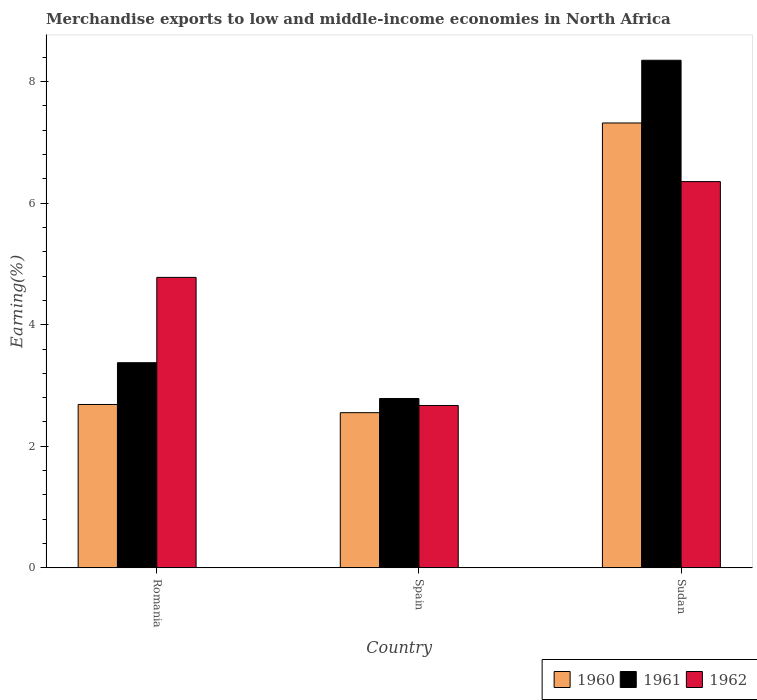How many groups of bars are there?
Keep it short and to the point. 3. Are the number of bars per tick equal to the number of legend labels?
Provide a short and direct response. Yes. How many bars are there on the 3rd tick from the left?
Your response must be concise. 3. How many bars are there on the 3rd tick from the right?
Offer a very short reply. 3. What is the label of the 3rd group of bars from the left?
Make the answer very short. Sudan. In how many cases, is the number of bars for a given country not equal to the number of legend labels?
Offer a very short reply. 0. What is the percentage of amount earned from merchandise exports in 1962 in Sudan?
Your response must be concise. 6.35. Across all countries, what is the maximum percentage of amount earned from merchandise exports in 1962?
Ensure brevity in your answer.  6.35. Across all countries, what is the minimum percentage of amount earned from merchandise exports in 1962?
Keep it short and to the point. 2.67. In which country was the percentage of amount earned from merchandise exports in 1962 maximum?
Ensure brevity in your answer.  Sudan. What is the total percentage of amount earned from merchandise exports in 1960 in the graph?
Your answer should be very brief. 12.56. What is the difference between the percentage of amount earned from merchandise exports in 1961 in Romania and that in Sudan?
Make the answer very short. -4.98. What is the difference between the percentage of amount earned from merchandise exports in 1962 in Romania and the percentage of amount earned from merchandise exports in 1960 in Sudan?
Your answer should be compact. -2.54. What is the average percentage of amount earned from merchandise exports in 1962 per country?
Your response must be concise. 4.6. What is the difference between the percentage of amount earned from merchandise exports of/in 1962 and percentage of amount earned from merchandise exports of/in 1960 in Spain?
Ensure brevity in your answer.  0.12. In how many countries, is the percentage of amount earned from merchandise exports in 1961 greater than 6.8 %?
Provide a succinct answer. 1. What is the ratio of the percentage of amount earned from merchandise exports in 1961 in Romania to that in Spain?
Your answer should be compact. 1.21. Is the difference between the percentage of amount earned from merchandise exports in 1962 in Romania and Sudan greater than the difference between the percentage of amount earned from merchandise exports in 1960 in Romania and Sudan?
Keep it short and to the point. Yes. What is the difference between the highest and the second highest percentage of amount earned from merchandise exports in 1961?
Your response must be concise. 5.57. What is the difference between the highest and the lowest percentage of amount earned from merchandise exports in 1962?
Your response must be concise. 3.68. In how many countries, is the percentage of amount earned from merchandise exports in 1961 greater than the average percentage of amount earned from merchandise exports in 1961 taken over all countries?
Keep it short and to the point. 1. Is it the case that in every country, the sum of the percentage of amount earned from merchandise exports in 1960 and percentage of amount earned from merchandise exports in 1962 is greater than the percentage of amount earned from merchandise exports in 1961?
Offer a terse response. Yes. What is the difference between two consecutive major ticks on the Y-axis?
Offer a very short reply. 2. Does the graph contain any zero values?
Provide a short and direct response. No. Does the graph contain grids?
Ensure brevity in your answer.  No. Where does the legend appear in the graph?
Ensure brevity in your answer.  Bottom right. How many legend labels are there?
Provide a short and direct response. 3. What is the title of the graph?
Make the answer very short. Merchandise exports to low and middle-income economies in North Africa. What is the label or title of the X-axis?
Ensure brevity in your answer.  Country. What is the label or title of the Y-axis?
Keep it short and to the point. Earning(%). What is the Earning(%) in 1960 in Romania?
Make the answer very short. 2.69. What is the Earning(%) in 1961 in Romania?
Provide a short and direct response. 3.37. What is the Earning(%) in 1962 in Romania?
Your answer should be compact. 4.78. What is the Earning(%) of 1960 in Spain?
Offer a terse response. 2.55. What is the Earning(%) of 1961 in Spain?
Make the answer very short. 2.79. What is the Earning(%) of 1962 in Spain?
Your answer should be compact. 2.67. What is the Earning(%) of 1960 in Sudan?
Provide a short and direct response. 7.32. What is the Earning(%) in 1961 in Sudan?
Offer a very short reply. 8.35. What is the Earning(%) of 1962 in Sudan?
Provide a succinct answer. 6.35. Across all countries, what is the maximum Earning(%) in 1960?
Offer a terse response. 7.32. Across all countries, what is the maximum Earning(%) of 1961?
Your answer should be compact. 8.35. Across all countries, what is the maximum Earning(%) in 1962?
Ensure brevity in your answer.  6.35. Across all countries, what is the minimum Earning(%) of 1960?
Your response must be concise. 2.55. Across all countries, what is the minimum Earning(%) in 1961?
Offer a very short reply. 2.79. Across all countries, what is the minimum Earning(%) in 1962?
Keep it short and to the point. 2.67. What is the total Earning(%) in 1960 in the graph?
Ensure brevity in your answer.  12.56. What is the total Earning(%) of 1961 in the graph?
Your answer should be very brief. 14.51. What is the total Earning(%) in 1962 in the graph?
Offer a very short reply. 13.8. What is the difference between the Earning(%) in 1960 in Romania and that in Spain?
Provide a short and direct response. 0.13. What is the difference between the Earning(%) in 1961 in Romania and that in Spain?
Your response must be concise. 0.59. What is the difference between the Earning(%) of 1962 in Romania and that in Spain?
Make the answer very short. 2.11. What is the difference between the Earning(%) of 1960 in Romania and that in Sudan?
Ensure brevity in your answer.  -4.63. What is the difference between the Earning(%) of 1961 in Romania and that in Sudan?
Provide a short and direct response. -4.98. What is the difference between the Earning(%) in 1962 in Romania and that in Sudan?
Provide a short and direct response. -1.58. What is the difference between the Earning(%) in 1960 in Spain and that in Sudan?
Provide a short and direct response. -4.77. What is the difference between the Earning(%) of 1961 in Spain and that in Sudan?
Offer a very short reply. -5.57. What is the difference between the Earning(%) in 1962 in Spain and that in Sudan?
Ensure brevity in your answer.  -3.68. What is the difference between the Earning(%) in 1960 in Romania and the Earning(%) in 1961 in Spain?
Offer a very short reply. -0.1. What is the difference between the Earning(%) of 1960 in Romania and the Earning(%) of 1962 in Spain?
Your answer should be compact. 0.02. What is the difference between the Earning(%) in 1961 in Romania and the Earning(%) in 1962 in Spain?
Give a very brief answer. 0.7. What is the difference between the Earning(%) of 1960 in Romania and the Earning(%) of 1961 in Sudan?
Provide a short and direct response. -5.67. What is the difference between the Earning(%) of 1960 in Romania and the Earning(%) of 1962 in Sudan?
Provide a short and direct response. -3.67. What is the difference between the Earning(%) of 1961 in Romania and the Earning(%) of 1962 in Sudan?
Keep it short and to the point. -2.98. What is the difference between the Earning(%) in 1960 in Spain and the Earning(%) in 1961 in Sudan?
Ensure brevity in your answer.  -5.8. What is the difference between the Earning(%) of 1960 in Spain and the Earning(%) of 1962 in Sudan?
Ensure brevity in your answer.  -3.8. What is the difference between the Earning(%) of 1961 in Spain and the Earning(%) of 1962 in Sudan?
Offer a very short reply. -3.57. What is the average Earning(%) in 1960 per country?
Provide a short and direct response. 4.19. What is the average Earning(%) in 1961 per country?
Your answer should be compact. 4.84. What is the average Earning(%) of 1962 per country?
Keep it short and to the point. 4.6. What is the difference between the Earning(%) in 1960 and Earning(%) in 1961 in Romania?
Provide a short and direct response. -0.69. What is the difference between the Earning(%) of 1960 and Earning(%) of 1962 in Romania?
Ensure brevity in your answer.  -2.09. What is the difference between the Earning(%) of 1961 and Earning(%) of 1962 in Romania?
Provide a short and direct response. -1.4. What is the difference between the Earning(%) of 1960 and Earning(%) of 1961 in Spain?
Give a very brief answer. -0.23. What is the difference between the Earning(%) of 1960 and Earning(%) of 1962 in Spain?
Your answer should be very brief. -0.12. What is the difference between the Earning(%) of 1961 and Earning(%) of 1962 in Spain?
Your answer should be compact. 0.11. What is the difference between the Earning(%) in 1960 and Earning(%) in 1961 in Sudan?
Make the answer very short. -1.03. What is the difference between the Earning(%) in 1960 and Earning(%) in 1962 in Sudan?
Your answer should be very brief. 0.96. What is the difference between the Earning(%) in 1961 and Earning(%) in 1962 in Sudan?
Offer a very short reply. 2. What is the ratio of the Earning(%) of 1960 in Romania to that in Spain?
Keep it short and to the point. 1.05. What is the ratio of the Earning(%) in 1961 in Romania to that in Spain?
Provide a succinct answer. 1.21. What is the ratio of the Earning(%) of 1962 in Romania to that in Spain?
Your answer should be compact. 1.79. What is the ratio of the Earning(%) of 1960 in Romania to that in Sudan?
Provide a short and direct response. 0.37. What is the ratio of the Earning(%) of 1961 in Romania to that in Sudan?
Your answer should be compact. 0.4. What is the ratio of the Earning(%) in 1962 in Romania to that in Sudan?
Offer a terse response. 0.75. What is the ratio of the Earning(%) of 1960 in Spain to that in Sudan?
Your answer should be very brief. 0.35. What is the ratio of the Earning(%) of 1961 in Spain to that in Sudan?
Offer a terse response. 0.33. What is the ratio of the Earning(%) of 1962 in Spain to that in Sudan?
Offer a very short reply. 0.42. What is the difference between the highest and the second highest Earning(%) in 1960?
Offer a very short reply. 4.63. What is the difference between the highest and the second highest Earning(%) in 1961?
Your answer should be compact. 4.98. What is the difference between the highest and the second highest Earning(%) of 1962?
Offer a very short reply. 1.58. What is the difference between the highest and the lowest Earning(%) of 1960?
Provide a succinct answer. 4.77. What is the difference between the highest and the lowest Earning(%) in 1961?
Provide a short and direct response. 5.57. What is the difference between the highest and the lowest Earning(%) in 1962?
Keep it short and to the point. 3.68. 